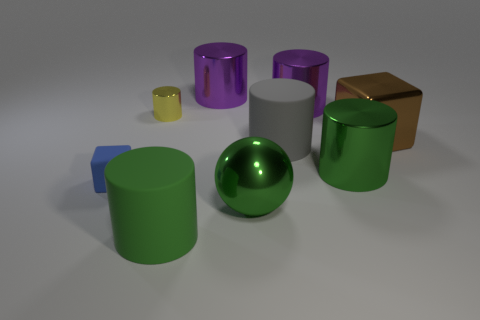Are there any other things that have the same material as the tiny cylinder?
Ensure brevity in your answer.  Yes. Is there anything else that has the same size as the blue rubber block?
Make the answer very short. Yes. Do the brown metal object and the tiny yellow object have the same shape?
Your answer should be compact. No. What is the color of the large block?
Your response must be concise. Brown. How many objects are large metal spheres or large purple rubber objects?
Provide a succinct answer. 1. Are there fewer purple metallic objects right of the big green metallic sphere than red rubber cylinders?
Offer a terse response. No. Is the number of small shiny cylinders that are right of the small yellow shiny thing greater than the number of blue matte blocks that are right of the small matte block?
Ensure brevity in your answer.  No. Are there any other things that have the same color as the small shiny object?
Provide a short and direct response. No. There is a tiny thing behind the big brown metal block; what is its material?
Give a very brief answer. Metal. Does the rubber cube have the same size as the gray object?
Give a very brief answer. No. 